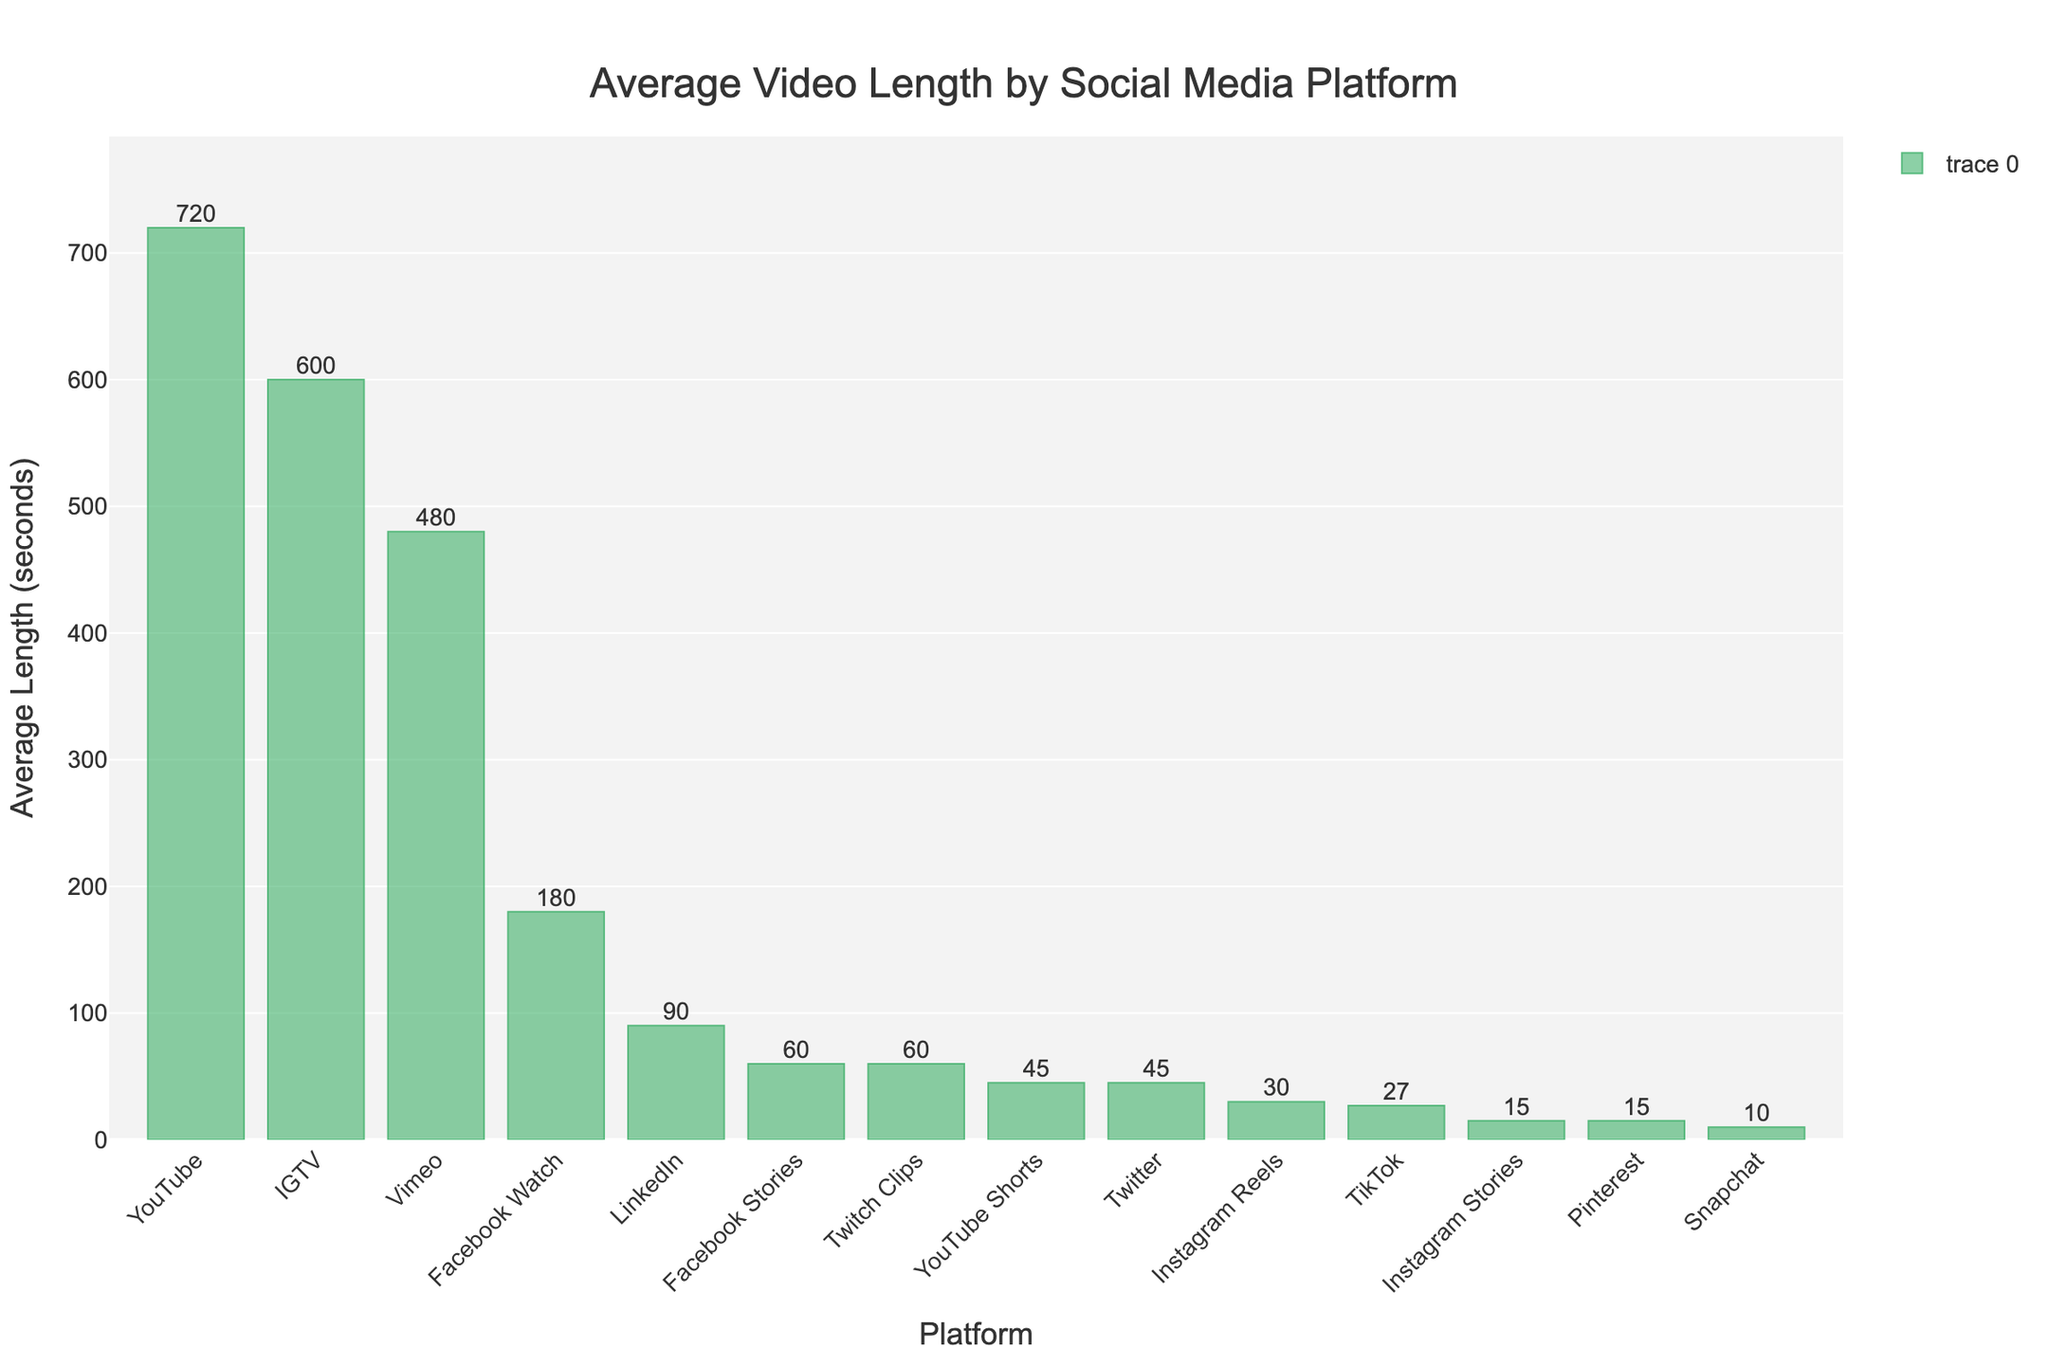How long is the average video length for TikTok compared to Snapchat? The average video length for TikTok is 27 seconds, and for Snapchat, it’s 10 seconds. Comparison shows TikTok videos are longer.
Answer: TikTok videos are 17 seconds longer Which platform has the longest average video length? Observing the bar chart, the platform with the highest bar indicates the longest average video length.
Answer: YouTube Which platform has a shorter average video length: Instagram Stories or Pinterest? Comparing the bars for Instagram Stories and Pinterest, both have the same average video length.
Answer: Both are equal What's the difference in average video lengths between Facebook Watch and IGTV? The Facebook Watch bar indicates 180 seconds and IGTV is at 600 seconds. Subtracting these gives the difference.
Answer: 420 seconds Which platform has the shortest average video length? Comparing all bars, the shortest bar corresponds to the platform with the shortest average video length.
Answer: Snapchat What’s the combined average video length of Instagram Reels and YouTube Shorts? The average lengths are 30 and 45 seconds respectively. Adding these gives the combined length.
Answer: 75 seconds Which platform has an average video length exactly 60 seconds long? Observing the bars, both Facebook Stories and Twitch Clips have their lengths at 60 seconds.
Answer: Facebook Stories and Twitch Clips How much longer is Vimeo's average video length compared to LinkedIn? Vimeo's bar shows 480 seconds, and LinkedIn's shows 90 seconds. Subtracting these gives the difference.
Answer: 390 seconds By what factor is YouTube's average video length longer than Instagram Reels? YouTube’s average length is 720 seconds and Instagram Reels is 30 seconds. Dividing YouTube’s length by Instagram Reels’ length gives the factor.
Answer: 24 times Which platform’s average video length is the closest to Twitter’s? The bar for Twitter is at 45 seconds, and the closest bar without exceeding it shows YouTube Shorts at the same value.
Answer: YouTube Shorts 